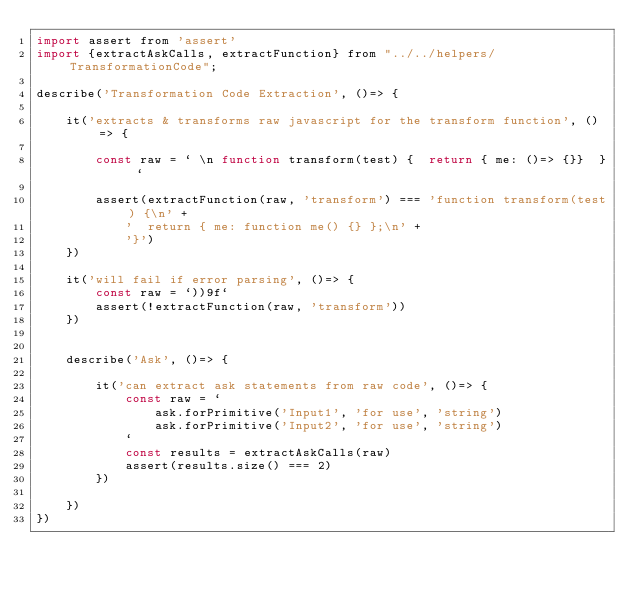Convert code to text. <code><loc_0><loc_0><loc_500><loc_500><_JavaScript_>import assert from 'assert'
import {extractAskCalls, extractFunction} from "../../helpers/TransformationCode";

describe('Transformation Code Extraction', ()=> {

	it('extracts & transforms raw javascript for the transform function', ()=> {

		const raw = ` \n function transform(test) {  return { me: ()=> {}}  } `

		assert(extractFunction(raw, 'transform') === 'function transform(test) {\n' +
			'  return { me: function me() {} };\n' +
			'}')
	})

	it('will fail if error parsing', ()=> {
		const raw = `))9f`
		assert(!extractFunction(raw, 'transform'))
	})


	describe('Ask', ()=> {

		it('can extract ask statements from raw code', ()=> {
			const raw = `
				ask.forPrimitive('Input1', 'for use', 'string')
				ask.forPrimitive('Input2', 'for use', 'string')
			`
			const results = extractAskCalls(raw)
			assert(results.size() === 2)
		})

	})
})</code> 